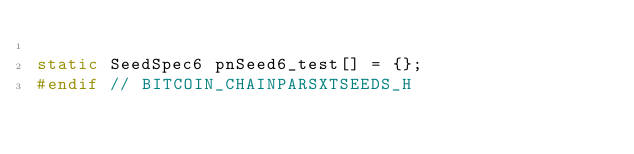<code> <loc_0><loc_0><loc_500><loc_500><_C_>
static SeedSpec6 pnSeed6_test[] = {};
#endif // BITCOIN_CHAINPARSXTSEEDS_H
</code> 